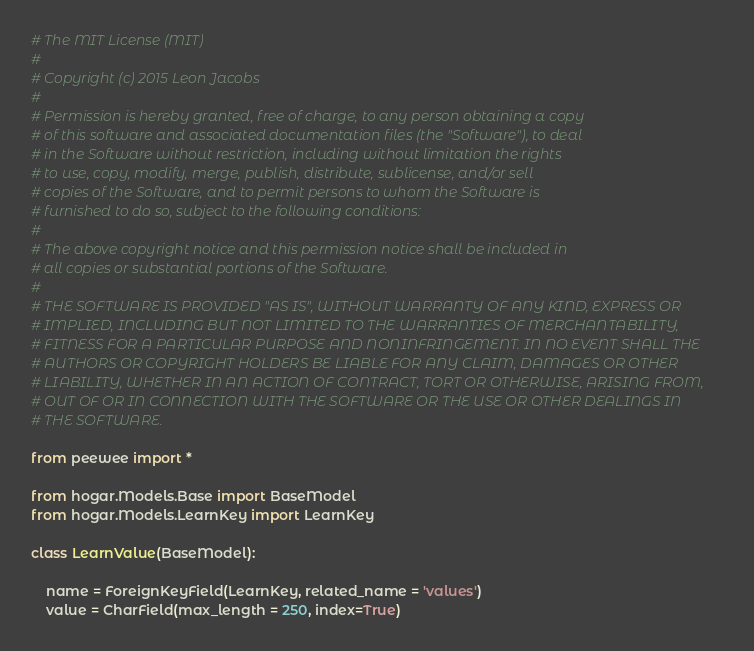<code> <loc_0><loc_0><loc_500><loc_500><_Python_># The MIT License (MIT)
#
# Copyright (c) 2015 Leon Jacobs
#
# Permission is hereby granted, free of charge, to any person obtaining a copy
# of this software and associated documentation files (the "Software"), to deal
# in the Software without restriction, including without limitation the rights
# to use, copy, modify, merge, publish, distribute, sublicense, and/or sell
# copies of the Software, and to permit persons to whom the Software is
# furnished to do so, subject to the following conditions:
#
# The above copyright notice and this permission notice shall be included in
# all copies or substantial portions of the Software.
#
# THE SOFTWARE IS PROVIDED "AS IS", WITHOUT WARRANTY OF ANY KIND, EXPRESS OR
# IMPLIED, INCLUDING BUT NOT LIMITED TO THE WARRANTIES OF MERCHANTABILITY,
# FITNESS FOR A PARTICULAR PURPOSE AND NONINFRINGEMENT. IN NO EVENT SHALL THE
# AUTHORS OR COPYRIGHT HOLDERS BE LIABLE FOR ANY CLAIM, DAMAGES OR OTHER
# LIABILITY, WHETHER IN AN ACTION OF CONTRACT, TORT OR OTHERWISE, ARISING FROM,
# OUT OF OR IN CONNECTION WITH THE SOFTWARE OR THE USE OR OTHER DEALINGS IN
# THE SOFTWARE.

from peewee import *

from hogar.Models.Base import BaseModel
from hogar.Models.LearnKey import LearnKey

class LearnValue(BaseModel):

    name = ForeignKeyField(LearnKey, related_name = 'values')
    value = CharField(max_length = 250, index=True)
</code> 